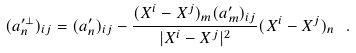<formula> <loc_0><loc_0><loc_500><loc_500>( a _ { n } ^ { \prime \perp } ) _ { i j } = ( a _ { n } ^ { \prime } ) _ { i j } - \frac { ( X ^ { i } - X ^ { j } ) _ { m } ( a _ { m } ^ { \prime } ) _ { i j } } { | X ^ { i } - X ^ { j } | ^ { 2 } } ( X ^ { i } - X ^ { j } ) _ { n } \ .</formula> 